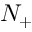Convert formula to latex. <formula><loc_0><loc_0><loc_500><loc_500>N _ { + }</formula> 